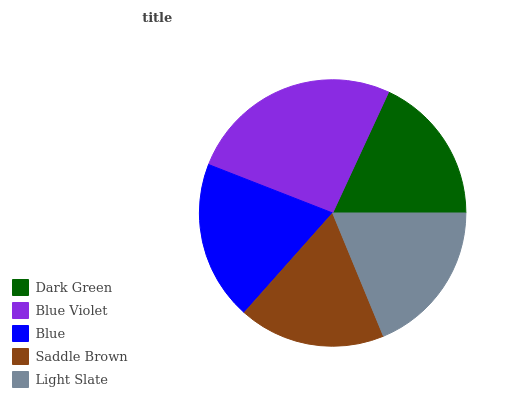Is Saddle Brown the minimum?
Answer yes or no. Yes. Is Blue Violet the maximum?
Answer yes or no. Yes. Is Blue the minimum?
Answer yes or no. No. Is Blue the maximum?
Answer yes or no. No. Is Blue Violet greater than Blue?
Answer yes or no. Yes. Is Blue less than Blue Violet?
Answer yes or no. Yes. Is Blue greater than Blue Violet?
Answer yes or no. No. Is Blue Violet less than Blue?
Answer yes or no. No. Is Light Slate the high median?
Answer yes or no. Yes. Is Light Slate the low median?
Answer yes or no. Yes. Is Dark Green the high median?
Answer yes or no. No. Is Saddle Brown the low median?
Answer yes or no. No. 